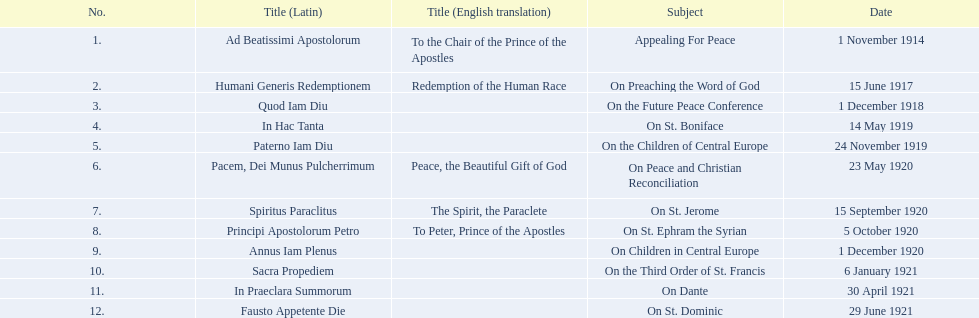How many titles lacked a listed english translation? 7. 